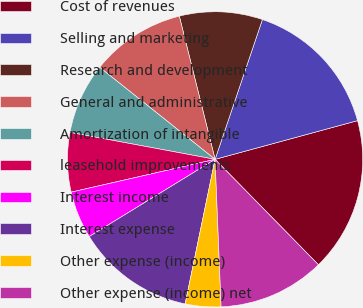Convert chart. <chart><loc_0><loc_0><loc_500><loc_500><pie_chart><fcel>Cost of revenues<fcel>Selling and marketing<fcel>Research and development<fcel>General and administrative<fcel>Amortization of intangible<fcel>leasehold improvements<fcel>Interest income<fcel>Interest expense<fcel>Other expense (income)<fcel>Other expense (income) net<nl><fcel>16.88%<fcel>15.58%<fcel>9.09%<fcel>10.39%<fcel>7.79%<fcel>6.49%<fcel>5.19%<fcel>12.99%<fcel>3.9%<fcel>11.69%<nl></chart> 